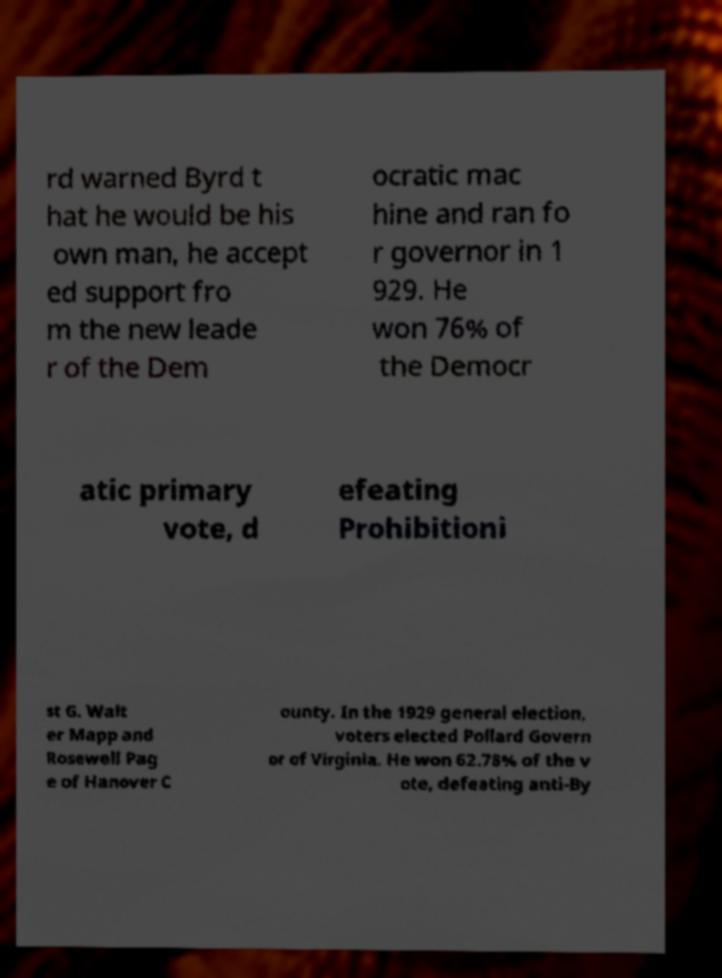I need the written content from this picture converted into text. Can you do that? rd warned Byrd t hat he would be his own man, he accept ed support fro m the new leade r of the Dem ocratic mac hine and ran fo r governor in 1 929. He won 76% of the Democr atic primary vote, d efeating Prohibitioni st G. Walt er Mapp and Rosewell Pag e of Hanover C ounty. In the 1929 general election, voters elected Pollard Govern or of Virginia. He won 62.78% of the v ote, defeating anti-By 